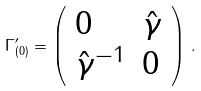Convert formula to latex. <formula><loc_0><loc_0><loc_500><loc_500>\Gamma _ { ( 0 ) } ^ { \prime } = \left ( \begin{array} { l l } { 0 } & { { \hat { \gamma } } } \\ { { \hat { \gamma } ^ { - 1 } } } & { 0 } \end{array} \right ) \, .</formula> 